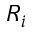<formula> <loc_0><loc_0><loc_500><loc_500>R _ { i }</formula> 